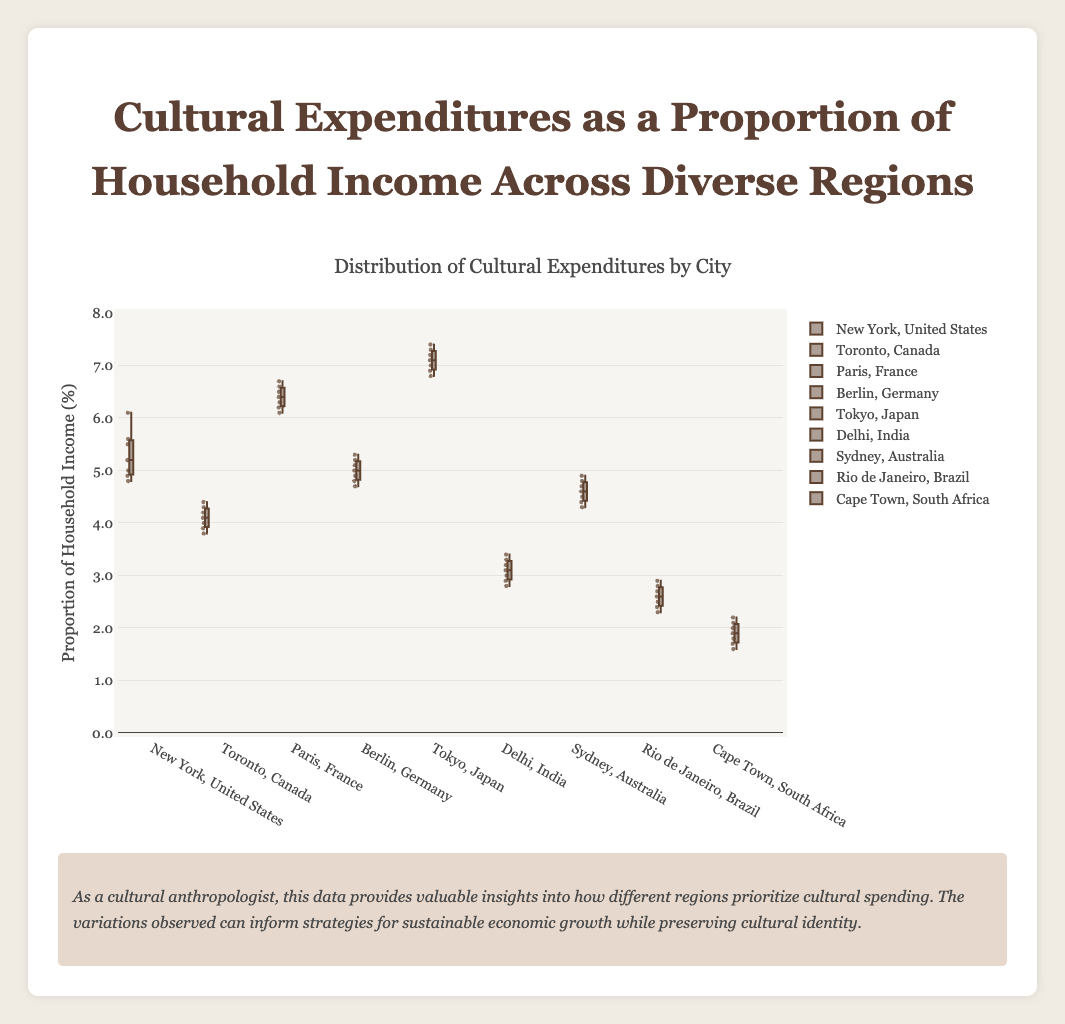Which region has the highest median cultural expenditure proportion? The box plot displays the median value as a line within the box. By observing which line is the highest on the y-axis, we can determine that Tokyo, Japan has the highest median cultural expenditure proportion.
Answer: Asia What is the range of cultural expenditure proportions for Rio de Janeiro, Brazil? The range in a box plot is found by subtracting the minimum value (bottom whisker) from the maximum value (top whisker). For Rio de Janeiro, the max is 2.9% and the min is 2.3%. Subtracting these gives a range of 0.6 percentage points.
Answer: 0.6% How does the median cultural expenditure proportion in Sydney, Australia compare to that of Berlin, Germany? To compare the medians, observe the horizontal lines within the boxes for each city. Berlin has a slightly lower median than Sydney.
Answer: Sydney is higher Which city shows the greatest variability in cultural expenditure proportions? The city with the largest interquartile range (IQR) has the greatest variability. This is shown by the height of the box. New York, USA has one of the largest IQRs.
Answer: New York What is the interquartile range (IQR) of cultural expenditure proportions for Paris, France? The IQR is calculated by subtracting the first quartile (bottom of the box) from the third quartile (top of the box). For Paris, this is from roughly 6.2% to 6.6%, giving an IQR of 0.4 percentage points.
Answer: 0.4% What proportion of household income does Cape Town, South Africa typically spend on cultural expenditures? The median value for Cape Town can be read directly from the box plot as the middle line in the box. This is around 1.9%.
Answer: 1.9% Which city in North America has higher cultural expenditure proportions? Examine the medians for New York and Toronto. New York has a higher median value than Toronto.
Answer: New York How many cities have cultural expenditure proportions below 2%? Cape Town, South Africa, is the only city with its box plot and whisker entirely below the 2% mark.
Answer: 1 What is the approximate 75th percentile for cultural expenditure in Tokyo, Japan? The 75th percentile is the top edge of the box, which for Tokyo is approximately around 7.3%.
Answer: 7.3% Which city has the smallest interquartile range (IQR) for cultural expenditure proportions? Look for the box with the smallest height. Rio de Janeiro, Brazil, has a very small IQR compared to other cities.
Answer: Rio de Janeiro 